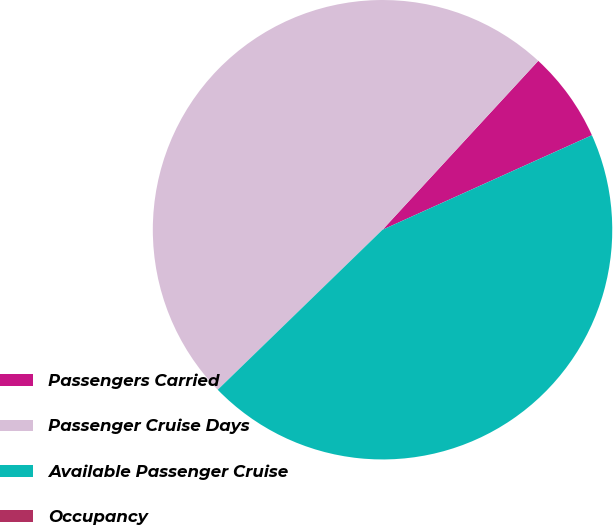<chart> <loc_0><loc_0><loc_500><loc_500><pie_chart><fcel>Passengers Carried<fcel>Passenger Cruise Days<fcel>Available Passenger Cruise<fcel>Occupancy<nl><fcel>6.4%<fcel>49.12%<fcel>44.48%<fcel>0.0%<nl></chart> 